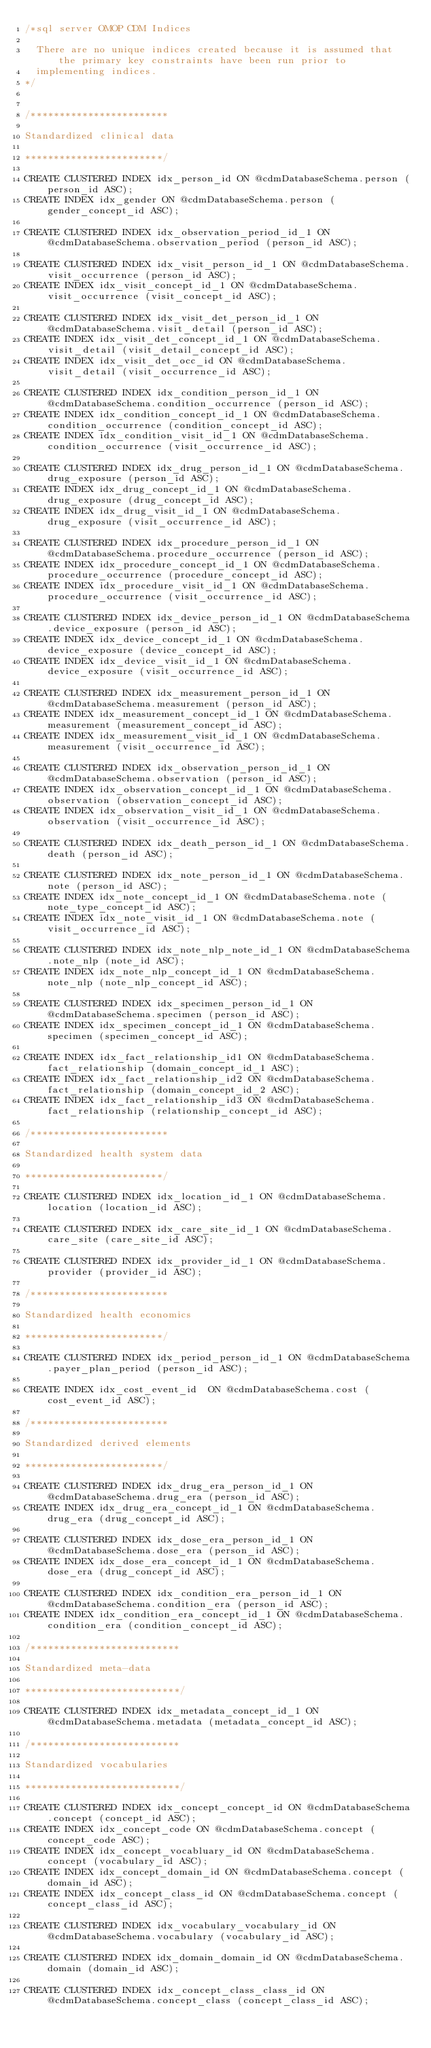Convert code to text. <code><loc_0><loc_0><loc_500><loc_500><_SQL_>/*sql server OMOP CDM Indices

  There are no unique indices created because it is assumed that the primary key constraints have been run prior to
  implementing indices.
*/


/************************

Standardized clinical data

************************/

CREATE CLUSTERED INDEX idx_person_id ON @cdmDatabaseSchema.person (person_id ASC);
CREATE INDEX idx_gender ON @cdmDatabaseSchema.person (gender_concept_id ASC);

CREATE CLUSTERED INDEX idx_observation_period_id_1 ON @cdmDatabaseSchema.observation_period (person_id ASC);

CREATE CLUSTERED INDEX idx_visit_person_id_1 ON @cdmDatabaseSchema.visit_occurrence (person_id ASC);
CREATE INDEX idx_visit_concept_id_1 ON @cdmDatabaseSchema.visit_occurrence (visit_concept_id ASC);

CREATE CLUSTERED INDEX idx_visit_det_person_id_1 ON @cdmDatabaseSchema.visit_detail (person_id ASC);
CREATE INDEX idx_visit_det_concept_id_1 ON @cdmDatabaseSchema.visit_detail (visit_detail_concept_id ASC);
CREATE INDEX idx_visit_det_occ_id ON @cdmDatabaseSchema.visit_detail (visit_occurrence_id ASC);

CREATE CLUSTERED INDEX idx_condition_person_id_1 ON @cdmDatabaseSchema.condition_occurrence (person_id ASC);
CREATE INDEX idx_condition_concept_id_1 ON @cdmDatabaseSchema.condition_occurrence (condition_concept_id ASC);
CREATE INDEX idx_condition_visit_id_1 ON @cdmDatabaseSchema.condition_occurrence (visit_occurrence_id ASC);

CREATE CLUSTERED INDEX idx_drug_person_id_1 ON @cdmDatabaseSchema.drug_exposure (person_id ASC);
CREATE INDEX idx_drug_concept_id_1 ON @cdmDatabaseSchema.drug_exposure (drug_concept_id ASC);
CREATE INDEX idx_drug_visit_id_1 ON @cdmDatabaseSchema.drug_exposure (visit_occurrence_id ASC);

CREATE CLUSTERED INDEX idx_procedure_person_id_1 ON @cdmDatabaseSchema.procedure_occurrence (person_id ASC);
CREATE INDEX idx_procedure_concept_id_1 ON @cdmDatabaseSchema.procedure_occurrence (procedure_concept_id ASC);
CREATE INDEX idx_procedure_visit_id_1 ON @cdmDatabaseSchema.procedure_occurrence (visit_occurrence_id ASC);

CREATE CLUSTERED INDEX idx_device_person_id_1 ON @cdmDatabaseSchema.device_exposure (person_id ASC);
CREATE INDEX idx_device_concept_id_1 ON @cdmDatabaseSchema.device_exposure (device_concept_id ASC);
CREATE INDEX idx_device_visit_id_1 ON @cdmDatabaseSchema.device_exposure (visit_occurrence_id ASC);

CREATE CLUSTERED INDEX idx_measurement_person_id_1 ON @cdmDatabaseSchema.measurement (person_id ASC);
CREATE INDEX idx_measurement_concept_id_1 ON @cdmDatabaseSchema.measurement (measurement_concept_id ASC);
CREATE INDEX idx_measurement_visit_id_1 ON @cdmDatabaseSchema.measurement (visit_occurrence_id ASC);

CREATE CLUSTERED INDEX idx_observation_person_id_1 ON @cdmDatabaseSchema.observation (person_id ASC);
CREATE INDEX idx_observation_concept_id_1 ON @cdmDatabaseSchema.observation (observation_concept_id ASC);
CREATE INDEX idx_observation_visit_id_1 ON @cdmDatabaseSchema.observation (visit_occurrence_id ASC);

CREATE CLUSTERED INDEX idx_death_person_id_1 ON @cdmDatabaseSchema.death (person_id ASC);

CREATE CLUSTERED INDEX idx_note_person_id_1 ON @cdmDatabaseSchema.note (person_id ASC);
CREATE INDEX idx_note_concept_id_1 ON @cdmDatabaseSchema.note (note_type_concept_id ASC);
CREATE INDEX idx_note_visit_id_1 ON @cdmDatabaseSchema.note (visit_occurrence_id ASC);

CREATE CLUSTERED INDEX idx_note_nlp_note_id_1 ON @cdmDatabaseSchema.note_nlp (note_id ASC);
CREATE INDEX idx_note_nlp_concept_id_1 ON @cdmDatabaseSchema.note_nlp (note_nlp_concept_id ASC);

CREATE CLUSTERED INDEX idx_specimen_person_id_1 ON @cdmDatabaseSchema.specimen (person_id ASC);
CREATE INDEX idx_specimen_concept_id_1 ON @cdmDatabaseSchema.specimen (specimen_concept_id ASC);

CREATE INDEX idx_fact_relationship_id1 ON @cdmDatabaseSchema.fact_relationship (domain_concept_id_1 ASC);
CREATE INDEX idx_fact_relationship_id2 ON @cdmDatabaseSchema.fact_relationship (domain_concept_id_2 ASC);
CREATE INDEX idx_fact_relationship_id3 ON @cdmDatabaseSchema.fact_relationship (relationship_concept_id ASC);

/************************

Standardized health system data

************************/

CREATE CLUSTERED INDEX idx_location_id_1 ON @cdmDatabaseSchema.location (location_id ASC);

CREATE CLUSTERED INDEX idx_care_site_id_1 ON @cdmDatabaseSchema.care_site (care_site_id ASC);

CREATE CLUSTERED INDEX idx_provider_id_1 ON @cdmDatabaseSchema.provider (provider_id ASC);

/************************

Standardized health economics

************************/

CREATE CLUSTERED INDEX idx_period_person_id_1 ON @cdmDatabaseSchema.payer_plan_period (person_id ASC);

CREATE INDEX idx_cost_event_id  ON @cdmDatabaseSchema.cost (cost_event_id ASC);

/************************

Standardized derived elements

************************/

CREATE CLUSTERED INDEX idx_drug_era_person_id_1 ON @cdmDatabaseSchema.drug_era (person_id ASC);
CREATE INDEX idx_drug_era_concept_id_1 ON @cdmDatabaseSchema.drug_era (drug_concept_id ASC);

CREATE CLUSTERED INDEX idx_dose_era_person_id_1 ON @cdmDatabaseSchema.dose_era (person_id ASC);
CREATE INDEX idx_dose_era_concept_id_1 ON @cdmDatabaseSchema.dose_era (drug_concept_id ASC);

CREATE CLUSTERED INDEX idx_condition_era_person_id_1 ON @cdmDatabaseSchema.condition_era (person_id ASC);
CREATE INDEX idx_condition_era_concept_id_1 ON @cdmDatabaseSchema.condition_era (condition_concept_id ASC);

/**************************

Standardized meta-data

***************************/

CREATE CLUSTERED INDEX idx_metadata_concept_id_1 ON @cdmDatabaseSchema.metadata (metadata_concept_id ASC);

/**************************

Standardized vocabularies

***************************/

CREATE CLUSTERED INDEX idx_concept_concept_id ON @cdmDatabaseSchema.concept (concept_id ASC);
CREATE INDEX idx_concept_code ON @cdmDatabaseSchema.concept (concept_code ASC);
CREATE INDEX idx_concept_vocabluary_id ON @cdmDatabaseSchema.concept (vocabulary_id ASC);
CREATE INDEX idx_concept_domain_id ON @cdmDatabaseSchema.concept (domain_id ASC);
CREATE INDEX idx_concept_class_id ON @cdmDatabaseSchema.concept (concept_class_id ASC);

CREATE CLUSTERED INDEX idx_vocabulary_vocabulary_id ON @cdmDatabaseSchema.vocabulary (vocabulary_id ASC);

CREATE CLUSTERED INDEX idx_domain_domain_id ON @cdmDatabaseSchema.domain (domain_id ASC);

CREATE CLUSTERED INDEX idx_concept_class_class_id ON @cdmDatabaseSchema.concept_class (concept_class_id ASC);
</code> 